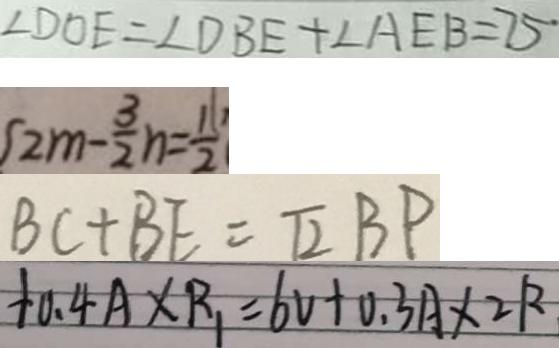<formula> <loc_0><loc_0><loc_500><loc_500>\angle D O E = \angle D B E + \angle A E B = 7 5 ^ { \circ } 
 2 m - \frac { 3 } { 2 } n = \frac { 1 } { 2 } 
 B C + B E = \sqrt { 2 } B P 
 + 0 . 4 A \times R _ { 1 } = 6 V + 0 . 3 A \times 2 R</formula> 